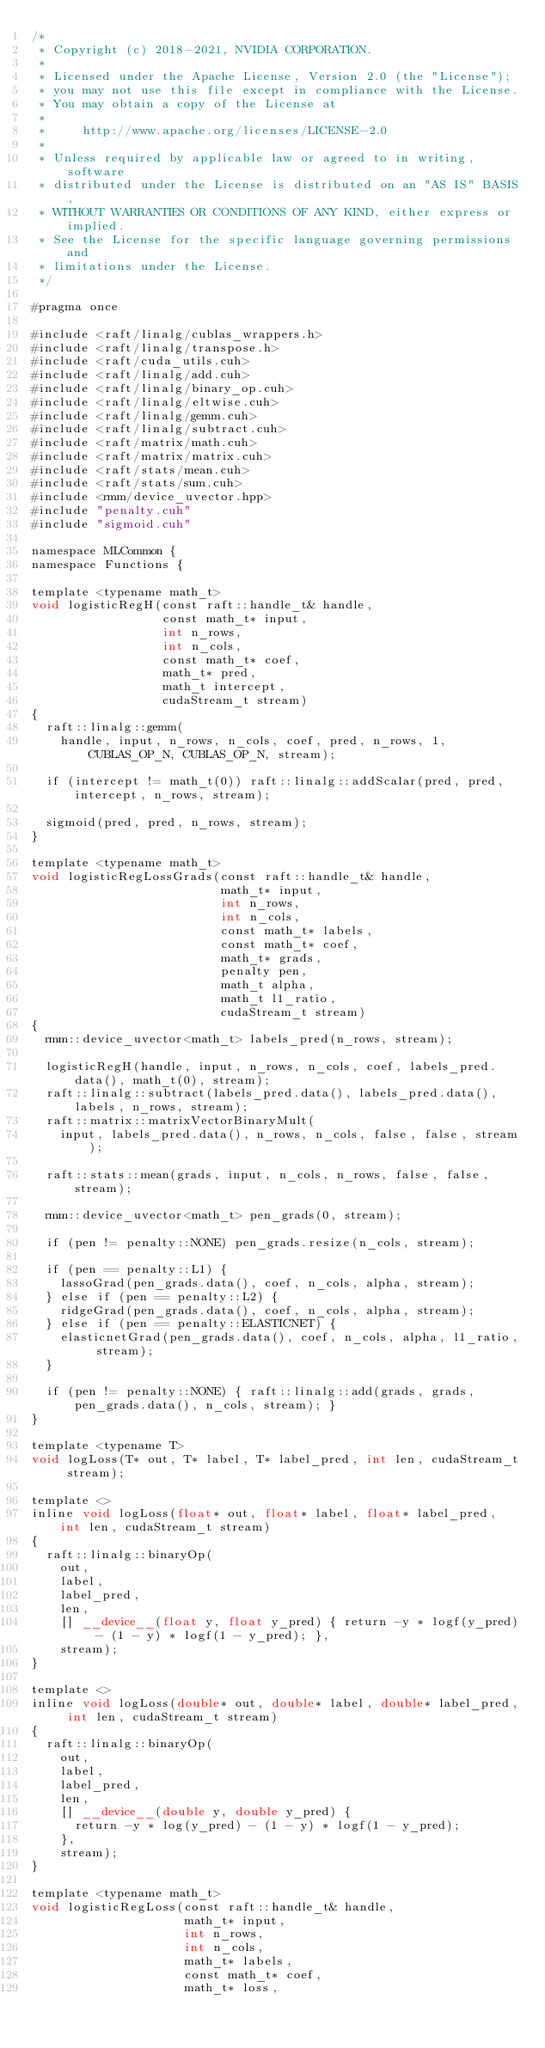<code> <loc_0><loc_0><loc_500><loc_500><_Cuda_>/*
 * Copyright (c) 2018-2021, NVIDIA CORPORATION.
 *
 * Licensed under the Apache License, Version 2.0 (the "License");
 * you may not use this file except in compliance with the License.
 * You may obtain a copy of the License at
 *
 *     http://www.apache.org/licenses/LICENSE-2.0
 *
 * Unless required by applicable law or agreed to in writing, software
 * distributed under the License is distributed on an "AS IS" BASIS,
 * WITHOUT WARRANTIES OR CONDITIONS OF ANY KIND, either express or implied.
 * See the License for the specific language governing permissions and
 * limitations under the License.
 */

#pragma once

#include <raft/linalg/cublas_wrappers.h>
#include <raft/linalg/transpose.h>
#include <raft/cuda_utils.cuh>
#include <raft/linalg/add.cuh>
#include <raft/linalg/binary_op.cuh>
#include <raft/linalg/eltwise.cuh>
#include <raft/linalg/gemm.cuh>
#include <raft/linalg/subtract.cuh>
#include <raft/matrix/math.cuh>
#include <raft/matrix/matrix.cuh>
#include <raft/stats/mean.cuh>
#include <raft/stats/sum.cuh>
#include <rmm/device_uvector.hpp>
#include "penalty.cuh"
#include "sigmoid.cuh"

namespace MLCommon {
namespace Functions {

template <typename math_t>
void logisticRegH(const raft::handle_t& handle,
                  const math_t* input,
                  int n_rows,
                  int n_cols,
                  const math_t* coef,
                  math_t* pred,
                  math_t intercept,
                  cudaStream_t stream)
{
  raft::linalg::gemm(
    handle, input, n_rows, n_cols, coef, pred, n_rows, 1, CUBLAS_OP_N, CUBLAS_OP_N, stream);

  if (intercept != math_t(0)) raft::linalg::addScalar(pred, pred, intercept, n_rows, stream);

  sigmoid(pred, pred, n_rows, stream);
}

template <typename math_t>
void logisticRegLossGrads(const raft::handle_t& handle,
                          math_t* input,
                          int n_rows,
                          int n_cols,
                          const math_t* labels,
                          const math_t* coef,
                          math_t* grads,
                          penalty pen,
                          math_t alpha,
                          math_t l1_ratio,
                          cudaStream_t stream)
{
  rmm::device_uvector<math_t> labels_pred(n_rows, stream);

  logisticRegH(handle, input, n_rows, n_cols, coef, labels_pred.data(), math_t(0), stream);
  raft::linalg::subtract(labels_pred.data(), labels_pred.data(), labels, n_rows, stream);
  raft::matrix::matrixVectorBinaryMult(
    input, labels_pred.data(), n_rows, n_cols, false, false, stream);

  raft::stats::mean(grads, input, n_cols, n_rows, false, false, stream);

  rmm::device_uvector<math_t> pen_grads(0, stream);

  if (pen != penalty::NONE) pen_grads.resize(n_cols, stream);

  if (pen == penalty::L1) {
    lassoGrad(pen_grads.data(), coef, n_cols, alpha, stream);
  } else if (pen == penalty::L2) {
    ridgeGrad(pen_grads.data(), coef, n_cols, alpha, stream);
  } else if (pen == penalty::ELASTICNET) {
    elasticnetGrad(pen_grads.data(), coef, n_cols, alpha, l1_ratio, stream);
  }

  if (pen != penalty::NONE) { raft::linalg::add(grads, grads, pen_grads.data(), n_cols, stream); }
}

template <typename T>
void logLoss(T* out, T* label, T* label_pred, int len, cudaStream_t stream);

template <>
inline void logLoss(float* out, float* label, float* label_pred, int len, cudaStream_t stream)
{
  raft::linalg::binaryOp(
    out,
    label,
    label_pred,
    len,
    [] __device__(float y, float y_pred) { return -y * logf(y_pred) - (1 - y) * logf(1 - y_pred); },
    stream);
}

template <>
inline void logLoss(double* out, double* label, double* label_pred, int len, cudaStream_t stream)
{
  raft::linalg::binaryOp(
    out,
    label,
    label_pred,
    len,
    [] __device__(double y, double y_pred) {
      return -y * log(y_pred) - (1 - y) * logf(1 - y_pred);
    },
    stream);
}

template <typename math_t>
void logisticRegLoss(const raft::handle_t& handle,
                     math_t* input,
                     int n_rows,
                     int n_cols,
                     math_t* labels,
                     const math_t* coef,
                     math_t* loss,</code> 